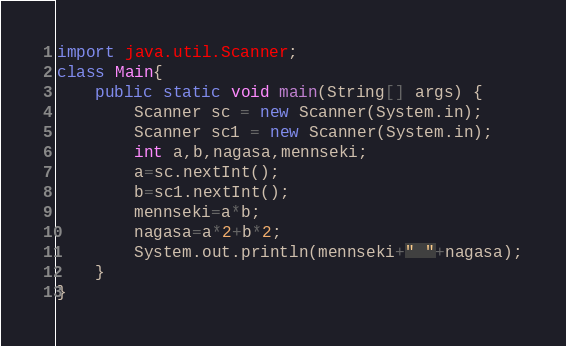<code> <loc_0><loc_0><loc_500><loc_500><_Java_>import java.util.Scanner;
class Main{
	public static void main(String[] args) {
		Scanner sc = new Scanner(System.in);
		Scanner sc1 = new Scanner(System.in);
		int a,b,nagasa,mennseki;
		a=sc.nextInt();
		b=sc1.nextInt();
		mennseki=a*b;
		nagasa=a*2+b*2;
		System.out.println(mennseki+" "+nagasa);
	}
}</code> 